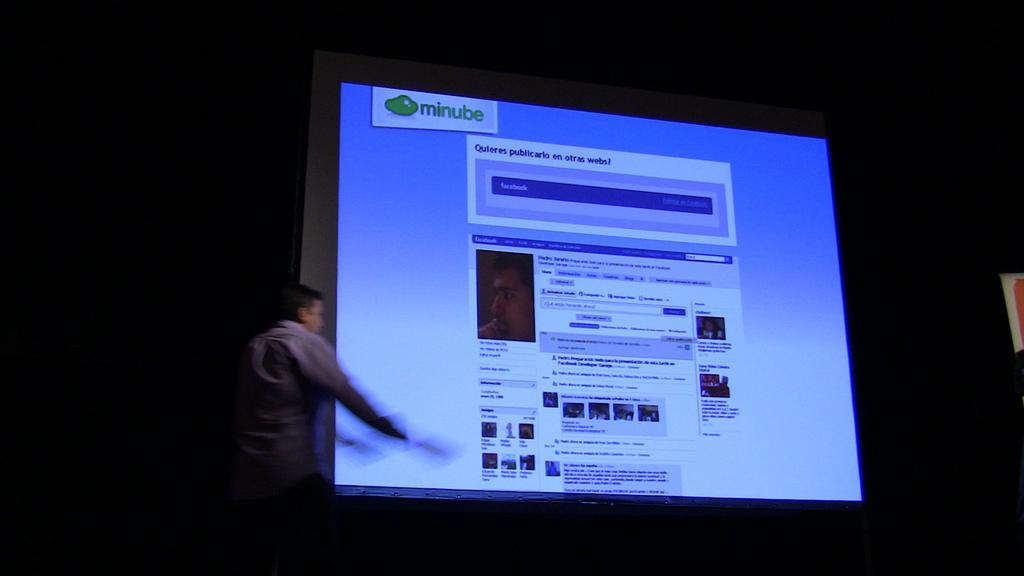<image>
Offer a succinct explanation of the picture presented. a large projector screen that says 'minube' on the top 